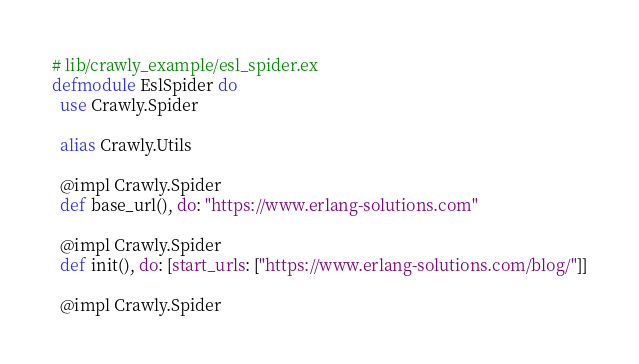<code> <loc_0><loc_0><loc_500><loc_500><_Elixir_># lib/crawly_example/esl_spider.ex
defmodule EslSpider do
  use Crawly.Spider

  alias Crawly.Utils

  @impl Crawly.Spider
  def base_url(), do: "https://www.erlang-solutions.com"

  @impl Crawly.Spider
  def init(), do: [start_urls: ["https://www.erlang-solutions.com/blog/"]]

  @impl Crawly.Spider</code> 